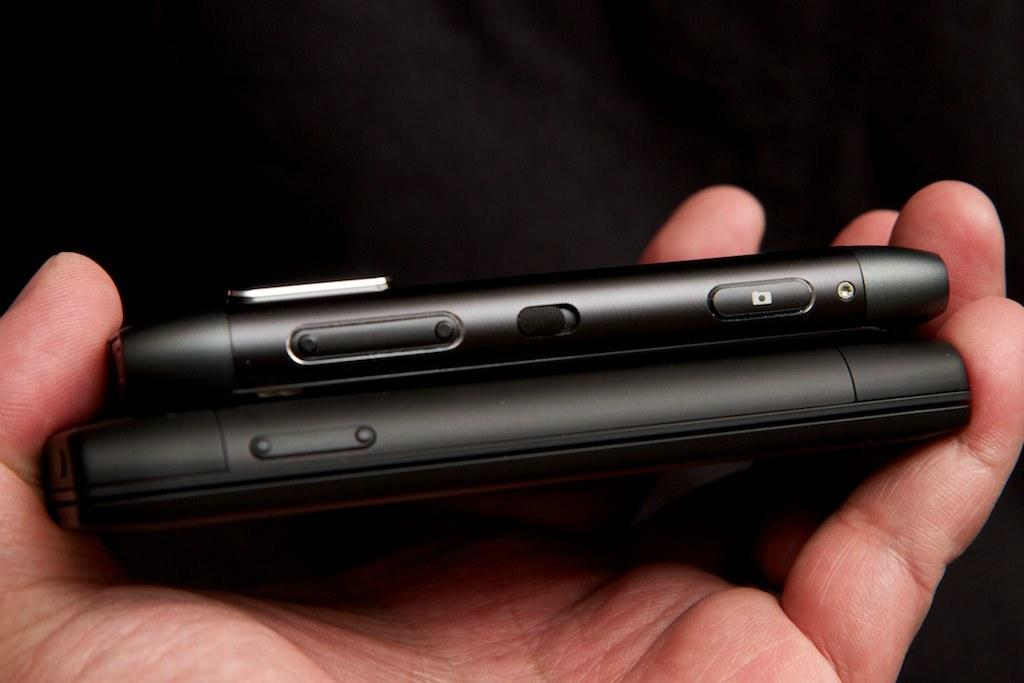What is the main subject of the image? The main subject of the image is the hand of a person. What is the hand holding? The hand is holding mobile phones. How many babies are visible in the image? There are no babies visible in the image; it only shows a hand holding mobile phones. What type of flower is being held by the hand in the image? There is no flower present in the image; the hand is holding mobile phones. 